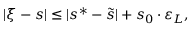<formula> <loc_0><loc_0><loc_500><loc_500>| \xi - s | \leq | s ^ { * } - \widetilde { s } | + s _ { 0 } \cdot \varepsilon _ { L } ,</formula> 